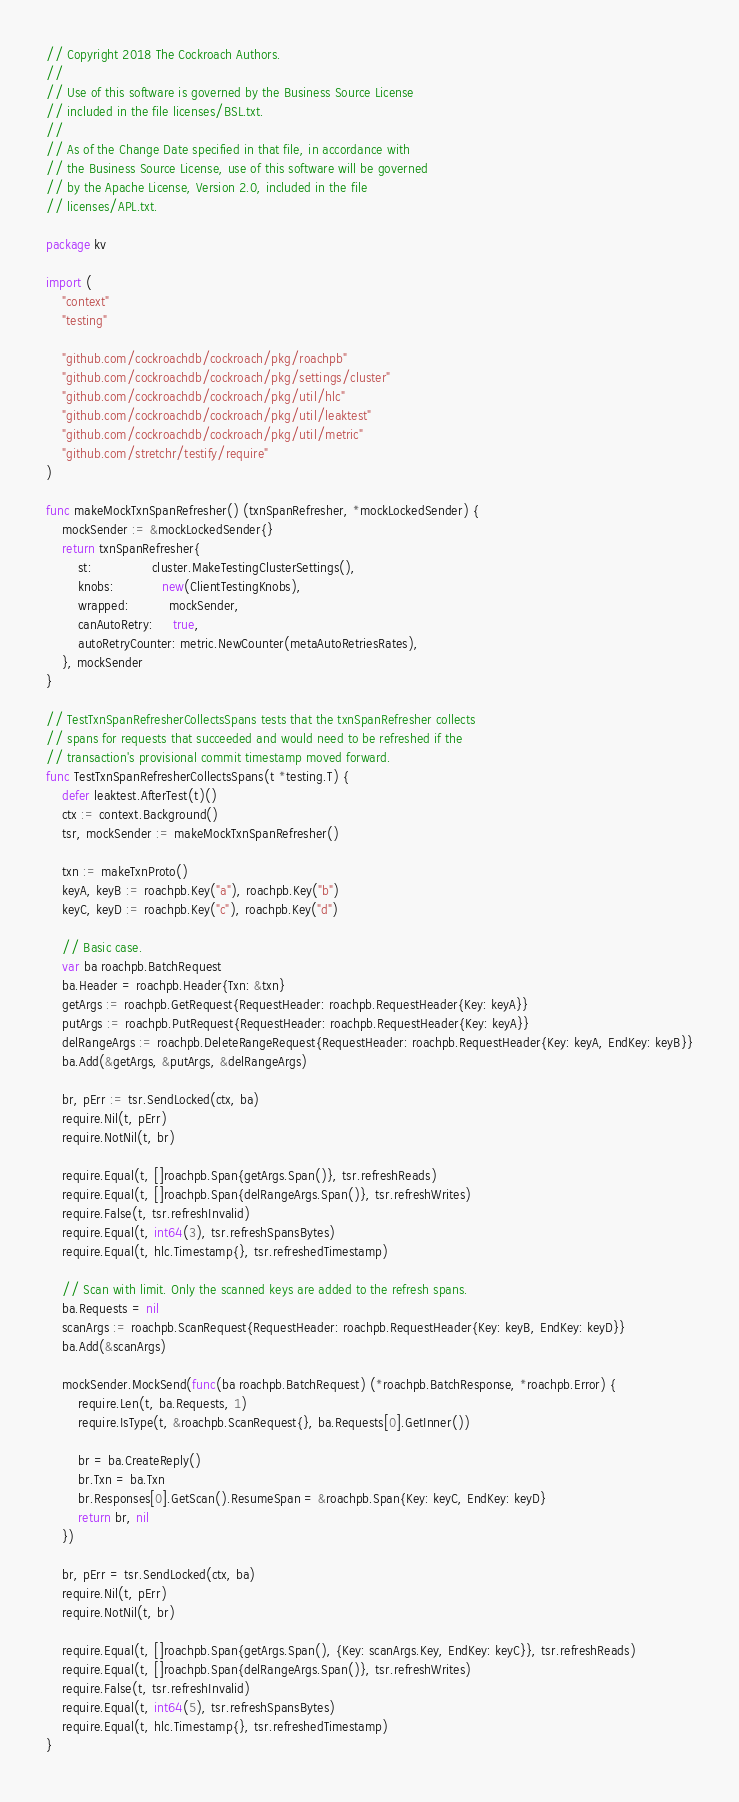<code> <loc_0><loc_0><loc_500><loc_500><_Go_>// Copyright 2018 The Cockroach Authors.
//
// Use of this software is governed by the Business Source License
// included in the file licenses/BSL.txt.
//
// As of the Change Date specified in that file, in accordance with
// the Business Source License, use of this software will be governed
// by the Apache License, Version 2.0, included in the file
// licenses/APL.txt.

package kv

import (
	"context"
	"testing"

	"github.com/cockroachdb/cockroach/pkg/roachpb"
	"github.com/cockroachdb/cockroach/pkg/settings/cluster"
	"github.com/cockroachdb/cockroach/pkg/util/hlc"
	"github.com/cockroachdb/cockroach/pkg/util/leaktest"
	"github.com/cockroachdb/cockroach/pkg/util/metric"
	"github.com/stretchr/testify/require"
)

func makeMockTxnSpanRefresher() (txnSpanRefresher, *mockLockedSender) {
	mockSender := &mockLockedSender{}
	return txnSpanRefresher{
		st:               cluster.MakeTestingClusterSettings(),
		knobs:            new(ClientTestingKnobs),
		wrapped:          mockSender,
		canAutoRetry:     true,
		autoRetryCounter: metric.NewCounter(metaAutoRetriesRates),
	}, mockSender
}

// TestTxnSpanRefresherCollectsSpans tests that the txnSpanRefresher collects
// spans for requests that succeeded and would need to be refreshed if the
// transaction's provisional commit timestamp moved forward.
func TestTxnSpanRefresherCollectsSpans(t *testing.T) {
	defer leaktest.AfterTest(t)()
	ctx := context.Background()
	tsr, mockSender := makeMockTxnSpanRefresher()

	txn := makeTxnProto()
	keyA, keyB := roachpb.Key("a"), roachpb.Key("b")
	keyC, keyD := roachpb.Key("c"), roachpb.Key("d")

	// Basic case.
	var ba roachpb.BatchRequest
	ba.Header = roachpb.Header{Txn: &txn}
	getArgs := roachpb.GetRequest{RequestHeader: roachpb.RequestHeader{Key: keyA}}
	putArgs := roachpb.PutRequest{RequestHeader: roachpb.RequestHeader{Key: keyA}}
	delRangeArgs := roachpb.DeleteRangeRequest{RequestHeader: roachpb.RequestHeader{Key: keyA, EndKey: keyB}}
	ba.Add(&getArgs, &putArgs, &delRangeArgs)

	br, pErr := tsr.SendLocked(ctx, ba)
	require.Nil(t, pErr)
	require.NotNil(t, br)

	require.Equal(t, []roachpb.Span{getArgs.Span()}, tsr.refreshReads)
	require.Equal(t, []roachpb.Span{delRangeArgs.Span()}, tsr.refreshWrites)
	require.False(t, tsr.refreshInvalid)
	require.Equal(t, int64(3), tsr.refreshSpansBytes)
	require.Equal(t, hlc.Timestamp{}, tsr.refreshedTimestamp)

	// Scan with limit. Only the scanned keys are added to the refresh spans.
	ba.Requests = nil
	scanArgs := roachpb.ScanRequest{RequestHeader: roachpb.RequestHeader{Key: keyB, EndKey: keyD}}
	ba.Add(&scanArgs)

	mockSender.MockSend(func(ba roachpb.BatchRequest) (*roachpb.BatchResponse, *roachpb.Error) {
		require.Len(t, ba.Requests, 1)
		require.IsType(t, &roachpb.ScanRequest{}, ba.Requests[0].GetInner())

		br = ba.CreateReply()
		br.Txn = ba.Txn
		br.Responses[0].GetScan().ResumeSpan = &roachpb.Span{Key: keyC, EndKey: keyD}
		return br, nil
	})

	br, pErr = tsr.SendLocked(ctx, ba)
	require.Nil(t, pErr)
	require.NotNil(t, br)

	require.Equal(t, []roachpb.Span{getArgs.Span(), {Key: scanArgs.Key, EndKey: keyC}}, tsr.refreshReads)
	require.Equal(t, []roachpb.Span{delRangeArgs.Span()}, tsr.refreshWrites)
	require.False(t, tsr.refreshInvalid)
	require.Equal(t, int64(5), tsr.refreshSpansBytes)
	require.Equal(t, hlc.Timestamp{}, tsr.refreshedTimestamp)
}
</code> 